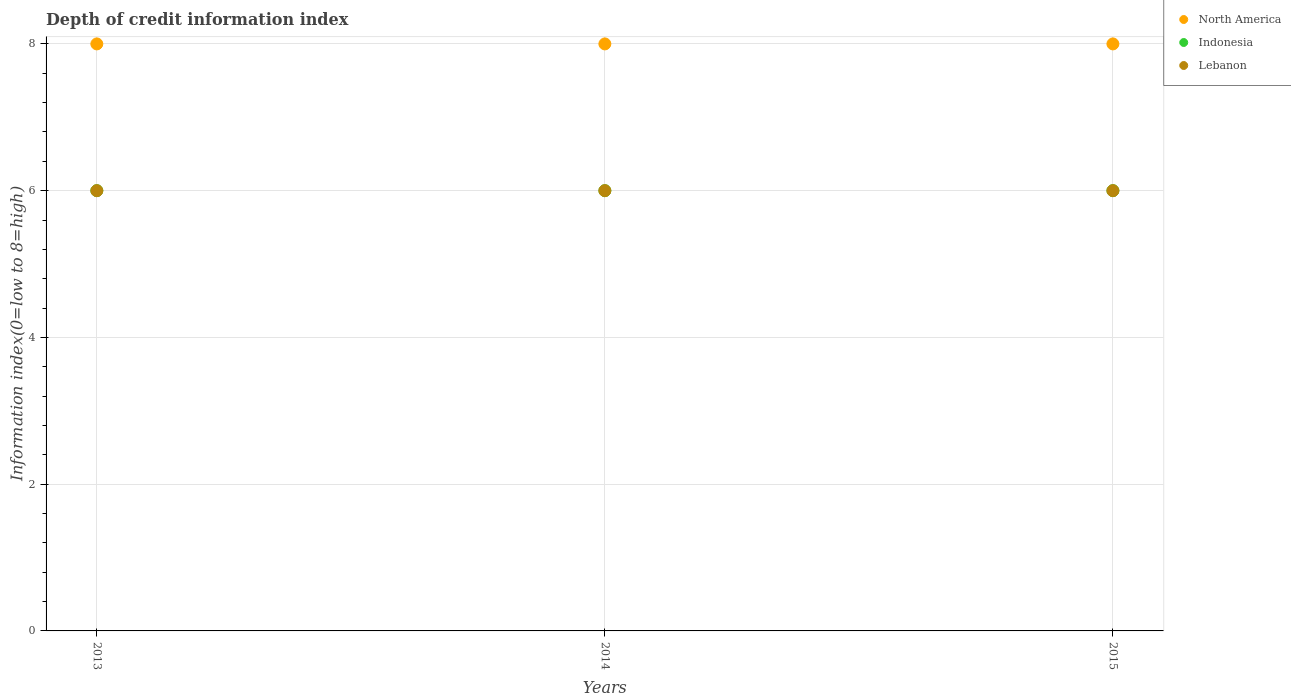Is the number of dotlines equal to the number of legend labels?
Your answer should be compact. Yes. What is the information index in North America in 2013?
Give a very brief answer. 8. Across all years, what is the maximum information index in North America?
Your answer should be very brief. 8. Across all years, what is the minimum information index in North America?
Your response must be concise. 8. In which year was the information index in Lebanon maximum?
Provide a succinct answer. 2013. In which year was the information index in Indonesia minimum?
Make the answer very short. 2013. What is the total information index in Indonesia in the graph?
Make the answer very short. 18. What is the average information index in North America per year?
Provide a short and direct response. 8. In the year 2015, what is the difference between the information index in Lebanon and information index in Indonesia?
Your answer should be compact. 0. What is the ratio of the information index in Lebanon in 2013 to that in 2014?
Make the answer very short. 1. What is the difference between the highest and the second highest information index in Lebanon?
Ensure brevity in your answer.  0. What is the difference between the highest and the lowest information index in Indonesia?
Offer a very short reply. 0. Is the sum of the information index in North America in 2013 and 2014 greater than the maximum information index in Lebanon across all years?
Make the answer very short. Yes. Does the information index in Lebanon monotonically increase over the years?
Keep it short and to the point. No. Is the information index in Indonesia strictly greater than the information index in Lebanon over the years?
Make the answer very short. No. Is the information index in Lebanon strictly less than the information index in North America over the years?
Your response must be concise. Yes. How many years are there in the graph?
Provide a short and direct response. 3. What is the difference between two consecutive major ticks on the Y-axis?
Offer a very short reply. 2. What is the title of the graph?
Make the answer very short. Depth of credit information index. What is the label or title of the Y-axis?
Offer a terse response. Information index(0=low to 8=high). What is the Information index(0=low to 8=high) of North America in 2014?
Give a very brief answer. 8. What is the Information index(0=low to 8=high) in Indonesia in 2014?
Offer a very short reply. 6. What is the Information index(0=low to 8=high) in North America in 2015?
Your answer should be compact. 8. What is the Information index(0=low to 8=high) in Indonesia in 2015?
Your answer should be very brief. 6. What is the Information index(0=low to 8=high) in Lebanon in 2015?
Make the answer very short. 6. Across all years, what is the maximum Information index(0=low to 8=high) of Indonesia?
Provide a succinct answer. 6. Across all years, what is the maximum Information index(0=low to 8=high) of Lebanon?
Your answer should be compact. 6. Across all years, what is the minimum Information index(0=low to 8=high) of Indonesia?
Your answer should be compact. 6. Across all years, what is the minimum Information index(0=low to 8=high) of Lebanon?
Keep it short and to the point. 6. What is the total Information index(0=low to 8=high) in North America in the graph?
Give a very brief answer. 24. What is the difference between the Information index(0=low to 8=high) of North America in 2013 and that in 2015?
Your answer should be compact. 0. What is the difference between the Information index(0=low to 8=high) of Indonesia in 2013 and that in 2015?
Your answer should be compact. 0. What is the difference between the Information index(0=low to 8=high) in Lebanon in 2014 and that in 2015?
Provide a succinct answer. 0. What is the difference between the Information index(0=low to 8=high) of North America in 2013 and the Information index(0=low to 8=high) of Indonesia in 2014?
Your response must be concise. 2. What is the difference between the Information index(0=low to 8=high) of North America in 2013 and the Information index(0=low to 8=high) of Lebanon in 2015?
Your answer should be compact. 2. What is the difference between the Information index(0=low to 8=high) of Indonesia in 2013 and the Information index(0=low to 8=high) of Lebanon in 2015?
Keep it short and to the point. 0. What is the difference between the Information index(0=low to 8=high) of North America in 2014 and the Information index(0=low to 8=high) of Lebanon in 2015?
Your answer should be very brief. 2. What is the average Information index(0=low to 8=high) of North America per year?
Offer a terse response. 8. What is the average Information index(0=low to 8=high) of Lebanon per year?
Your answer should be very brief. 6. In the year 2013, what is the difference between the Information index(0=low to 8=high) of North America and Information index(0=low to 8=high) of Indonesia?
Your response must be concise. 2. In the year 2014, what is the difference between the Information index(0=low to 8=high) of North America and Information index(0=low to 8=high) of Lebanon?
Your response must be concise. 2. In the year 2014, what is the difference between the Information index(0=low to 8=high) of Indonesia and Information index(0=low to 8=high) of Lebanon?
Provide a succinct answer. 0. In the year 2015, what is the difference between the Information index(0=low to 8=high) in North America and Information index(0=low to 8=high) in Lebanon?
Provide a short and direct response. 2. What is the ratio of the Information index(0=low to 8=high) in Indonesia in 2013 to that in 2015?
Keep it short and to the point. 1. What is the ratio of the Information index(0=low to 8=high) of Lebanon in 2013 to that in 2015?
Keep it short and to the point. 1. What is the difference between the highest and the second highest Information index(0=low to 8=high) in North America?
Make the answer very short. 0. What is the difference between the highest and the lowest Information index(0=low to 8=high) in Indonesia?
Make the answer very short. 0. 